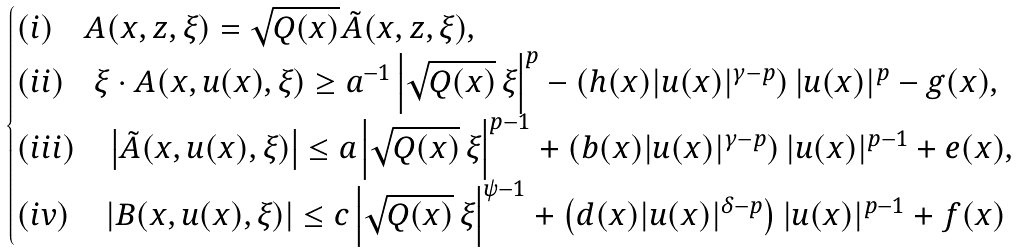<formula> <loc_0><loc_0><loc_500><loc_500>\begin{cases} ( i ) \quad A ( x , z , \xi ) = \sqrt { Q ( x ) } { \tilde { A } } ( x , z , \xi ) , \\ ( i i ) \quad \xi \cdot A ( x , u ( x ) , \xi ) \geq a ^ { - 1 } \left | \sqrt { Q ( x ) } \, \xi \right | ^ { p } - \left ( h ( x ) | u ( x ) | ^ { \gamma - p } \right ) | u ( x ) | ^ { p } - g ( x ) , \\ ( i i i ) \quad \left | \tilde { A } ( x , u ( x ) , \xi ) \right | \leq a \left | \sqrt { Q ( x ) } \, \xi \right | ^ { p - 1 } + \left ( b ( x ) | u ( x ) | ^ { \gamma - p } \right ) | u ( x ) | ^ { p - 1 } + e ( x ) , \\ ( i v ) \quad \left | B ( x , u ( x ) , \xi ) \right | \leq c \left | \sqrt { Q ( x ) } \, \xi \right | ^ { \psi - 1 } + \left ( d ( x ) | u ( x ) | ^ { \delta - p } \right ) | u ( x ) | ^ { p - 1 } + f ( x ) \end{cases}</formula> 